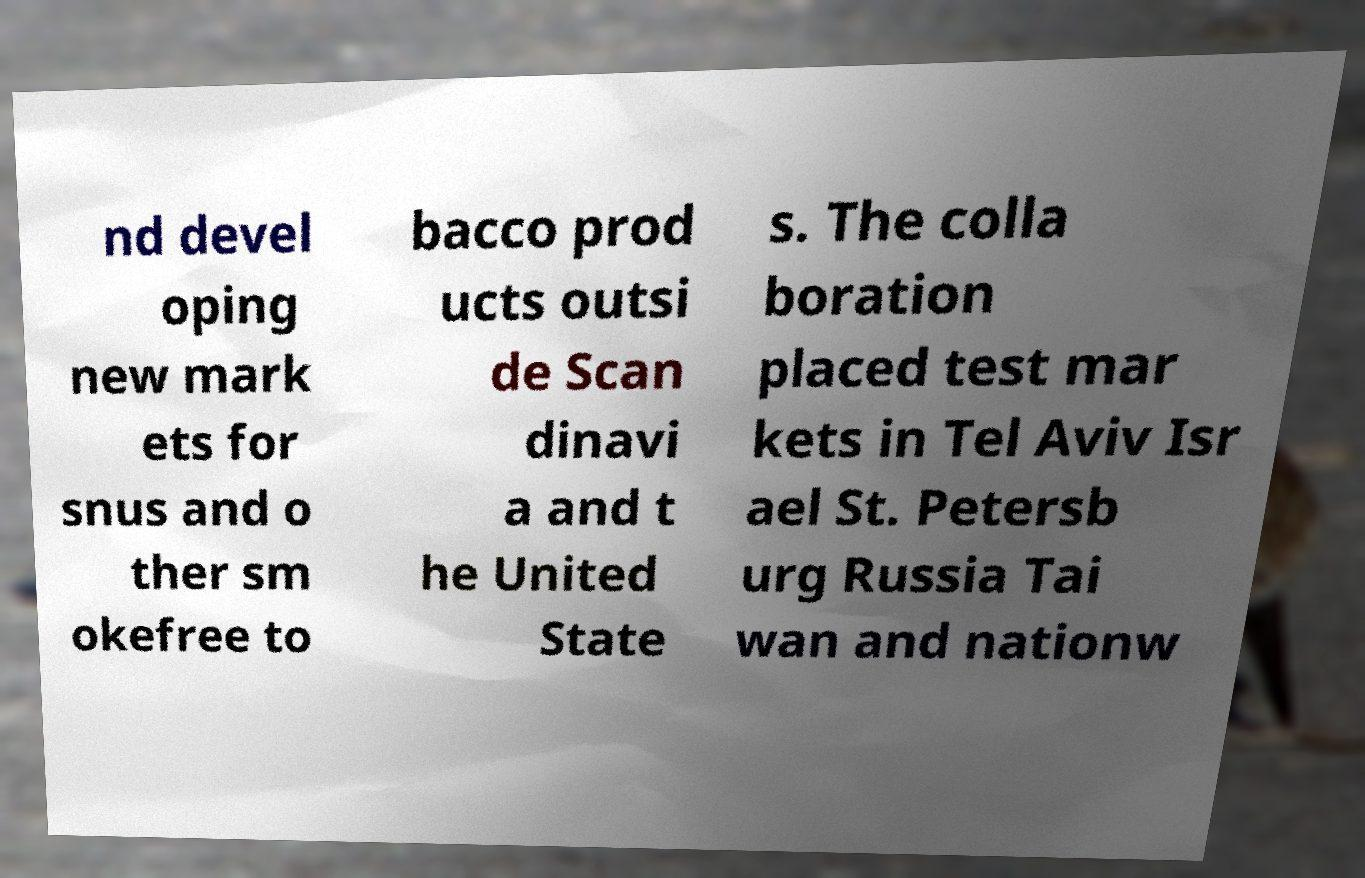I need the written content from this picture converted into text. Can you do that? nd devel oping new mark ets for snus and o ther sm okefree to bacco prod ucts outsi de Scan dinavi a and t he United State s. The colla boration placed test mar kets in Tel Aviv Isr ael St. Petersb urg Russia Tai wan and nationw 